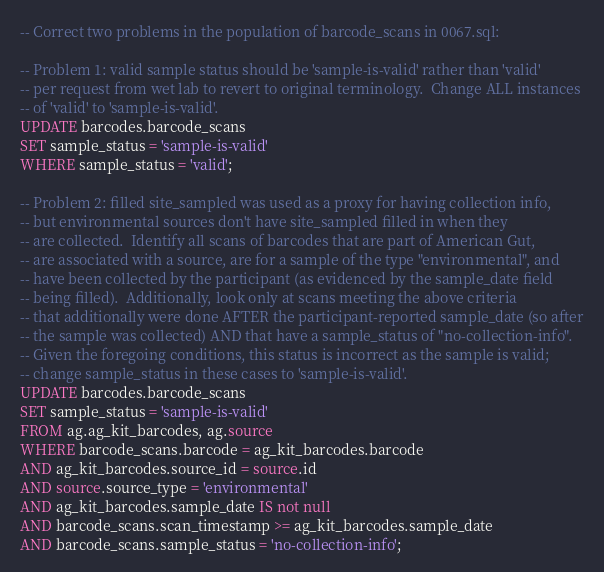<code> <loc_0><loc_0><loc_500><loc_500><_SQL_>-- Correct two problems in the population of barcode_scans in 0067.sql:

-- Problem 1: valid sample status should be 'sample-is-valid' rather than 'valid'
-- per request from wet lab to revert to original terminology.  Change ALL instances
-- of 'valid' to 'sample-is-valid'.
UPDATE barcodes.barcode_scans
SET sample_status = 'sample-is-valid'
WHERE sample_status = 'valid';

-- Problem 2: filled site_sampled was used as a proxy for having collection info,
-- but environmental sources don't have site_sampled filled in when they
-- are collected.  Identify all scans of barcodes that are part of American Gut,
-- are associated with a source, are for a sample of the type "environmental", and
-- have been collected by the participant (as evidenced by the sample_date field
-- being filled).  Additionally, look only at scans meeting the above criteria
-- that additionally were done AFTER the participant-reported sample_date (so after
-- the sample was collected) AND that have a sample_status of "no-collection-info".
-- Given the foregoing conditions, this status is incorrect as the sample is valid;
-- change sample_status in these cases to 'sample-is-valid'.
UPDATE barcodes.barcode_scans
SET sample_status = 'sample-is-valid'
FROM ag.ag_kit_barcodes, ag.source
WHERE barcode_scans.barcode = ag_kit_barcodes.barcode
AND ag_kit_barcodes.source_id = source.id
AND source.source_type = 'environmental'
AND ag_kit_barcodes.sample_date IS not null
AND barcode_scans.scan_timestamp >= ag_kit_barcodes.sample_date
AND barcode_scans.sample_status = 'no-collection-info';</code> 